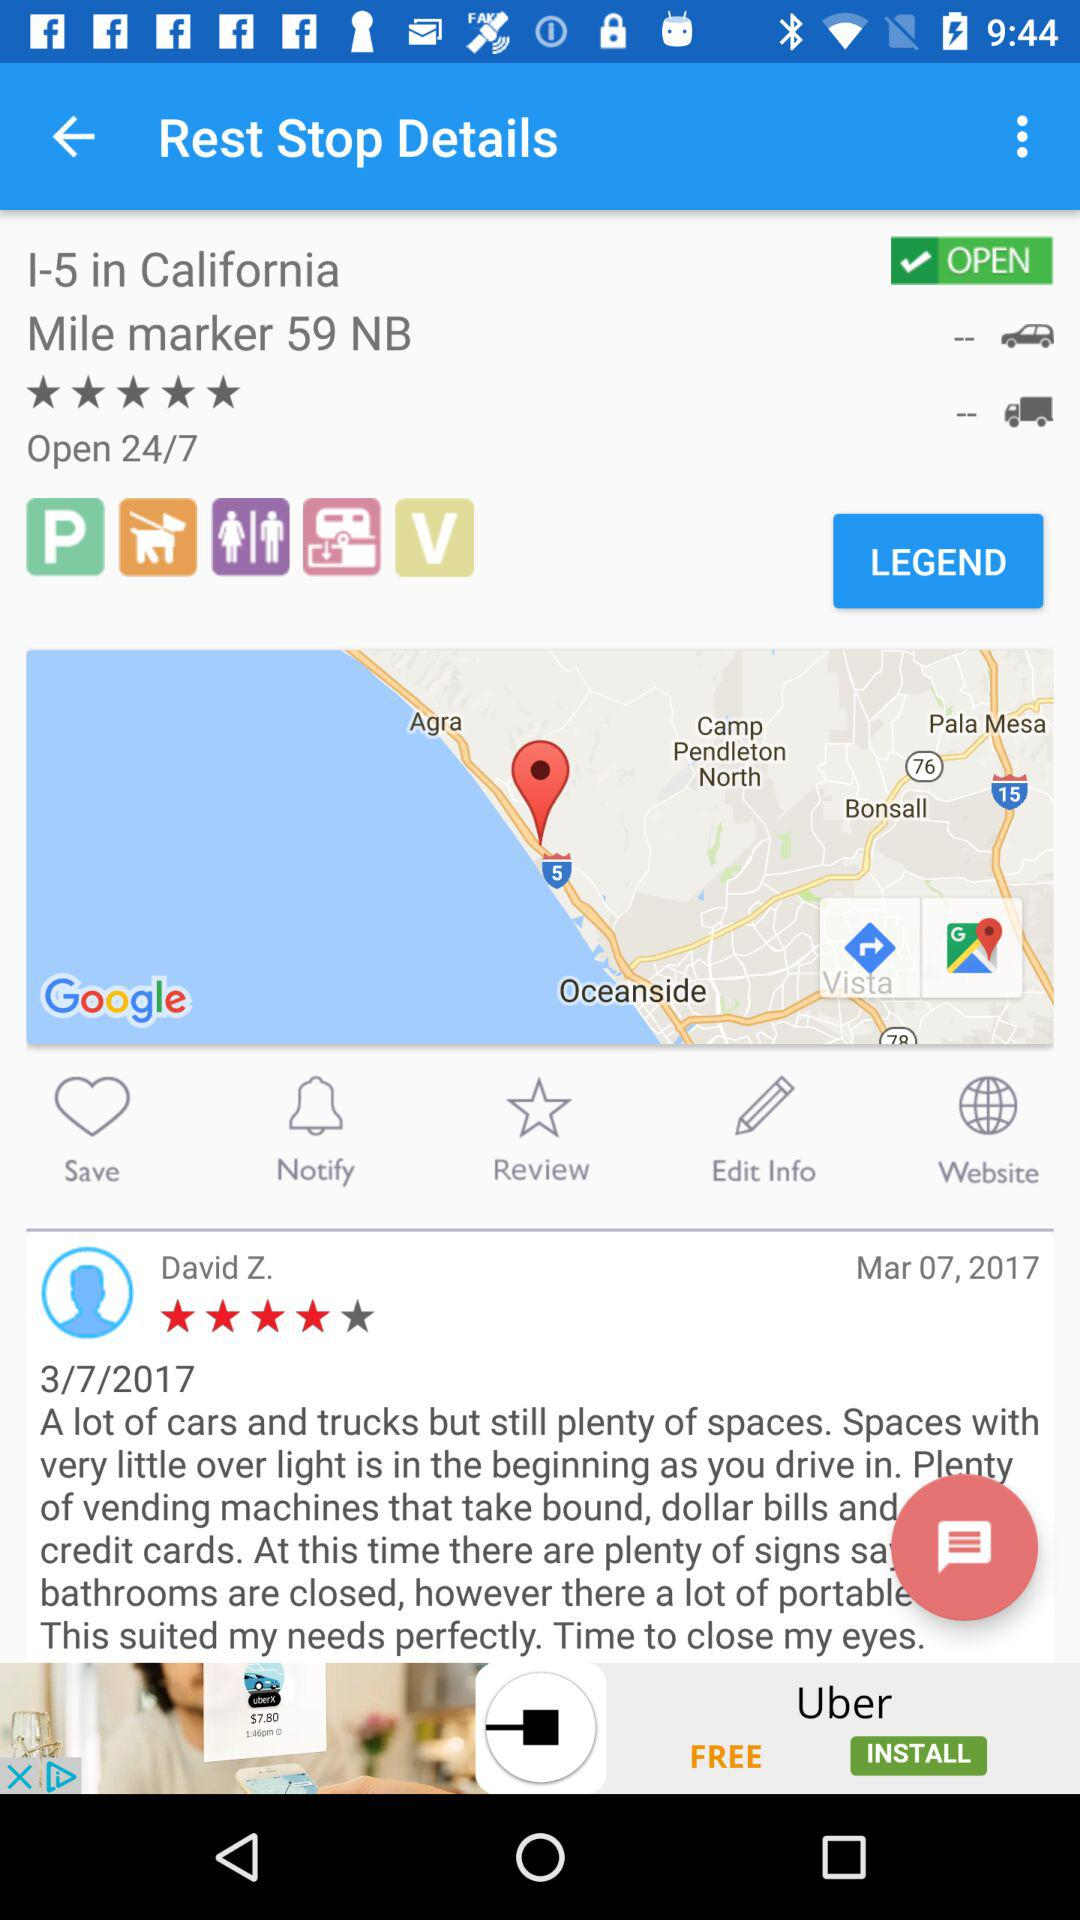How long is the shop open? The shop is open 24 hours a day, seven days a week. 